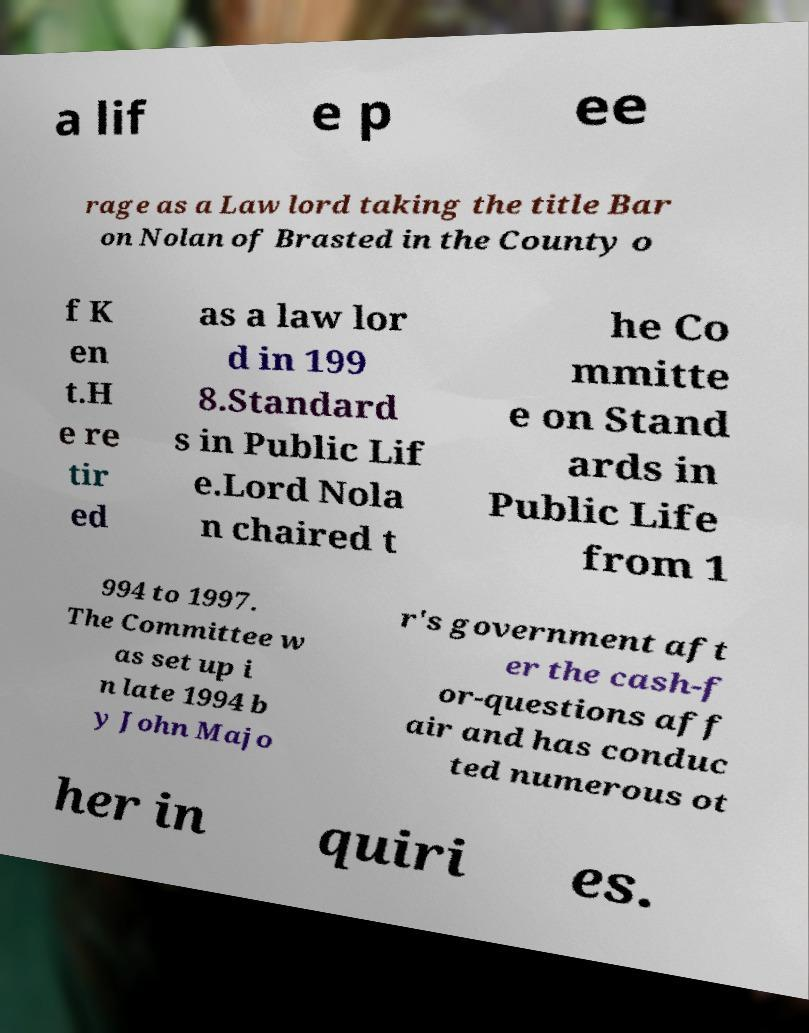Can you read and provide the text displayed in the image?This photo seems to have some interesting text. Can you extract and type it out for me? a lif e p ee rage as a Law lord taking the title Bar on Nolan of Brasted in the County o f K en t.H e re tir ed as a law lor d in 199 8.Standard s in Public Lif e.Lord Nola n chaired t he Co mmitte e on Stand ards in Public Life from 1 994 to 1997. The Committee w as set up i n late 1994 b y John Majo r's government aft er the cash-f or-questions aff air and has conduc ted numerous ot her in quiri es. 